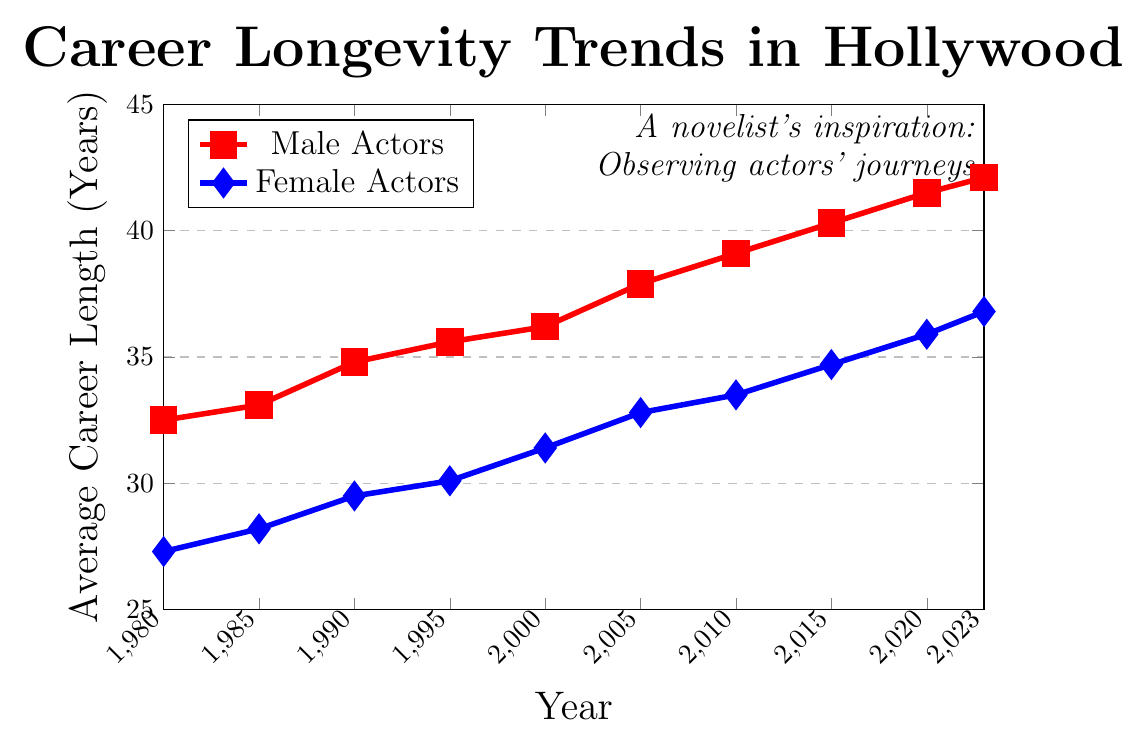What's the difference in average career length between male and female actors in 1980? The chart shows that in 1980, male actors had an average career length of 32.5 years, while female actors had an average career length of 27.3 years. The difference is calculated as 32.5 - 27.3.
Answer: 5.2 years Which group has shown a more significant increase in average career length from 1980 to 2023? To find which group showed a more significant increase, calculate the difference between the 2023 and 1980 values for both groups. For male actors, the increase is 42.1 - 32.5 = 9.6 years. For female actors, the increase is 36.8 - 27.3 = 9.5 years. Male actors show a slightly higher increase.
Answer: Male actors In 2005, by how many years did the average career length of male actors surpass that of female actors? In 2005, the average career length for male actors was 37.9 years, and for female actors, it was 32.8 years. Subtract the female value from the male value: 37.9 - 32.8.
Answer: 5.1 years What is the overall trend in average career length for male and female actors from 1980 to 2023, and which group has a steeper trend? The overall trend for both groups indicates an increase in average career length from 1980 to 2023. Calculate the slope for both groups to determine which trend is steeper: (42.1 - 32.5) / (2023 - 1980) = 9.6 / 43 = 0.223 years per year for males, and (36.8 - 27.3) / (43) = 9.5 / 43 = 0.221 years per year for females. The difference in slopes is marginal, but the rate of increase is slightly steeper for males.
Answer: Male actors In which years did female actors have an average career length of over 30 years? From the figure, female actors had an average career length of over 30 years starting from 1995 onwards (from 1995: 30.1 years to 2023: 36.8 years).
Answer: 1995 to 2023 What is the average career length of male actors in 2015, and how does it compare numerically to female actors in the same year? In 2015, the average career length for male actors is 40.3 years, and for female actors, it's 34.7 years. The difference is found by subtracting the female average from the male average: 40.3 - 34.7.
Answer: 5.6 years By examining the graph, what visual cue indicates which gender's career longevity has consistently been higher over the years? The red line representing male actors is consistently above the blue line representing female actors, indicating that male actors have had higher career longevity throughout the years from 1980 to 2023.
Answer: Red line is higher In 1990, how many years less was the average career length of female actors compared to male actors? The chart shows that in 1990, male actors had an average career length of 34.8 years, while female actors had an average career length of 29.5 years. The difference is calculated as 34.8 - 29.5.
Answer: 5.3 years What’s the general pattern of the two lines as you move from 1980 to 2023? As you move from 1980 to 2023, both lines (red for male actors and blue for female actors) show an upward trend, indicating an increase in average career length over time for both genders.
Answer: Upward trend Considering the years 2000 and 2010, what is the rate of increase in the average career length for male actors? For male actors, the increase from 2000 to 2010 is calculated by finding the difference in career lengths and dividing by the number of years: (39.1 - 36.2) / (2010 - 2000) = 2.9 / 10.
Answer: 0.29 years per year 